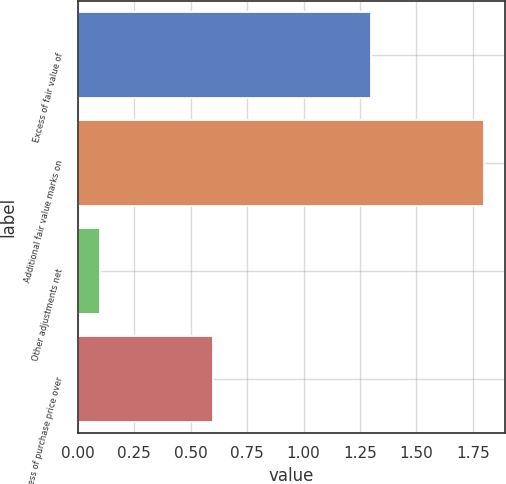Convert chart to OTSL. <chart><loc_0><loc_0><loc_500><loc_500><bar_chart><fcel>Excess of fair value of<fcel>Additional fair value marks on<fcel>Other adjustments net<fcel>Excess of purchase price over<nl><fcel>1.3<fcel>1.8<fcel>0.1<fcel>0.6<nl></chart> 